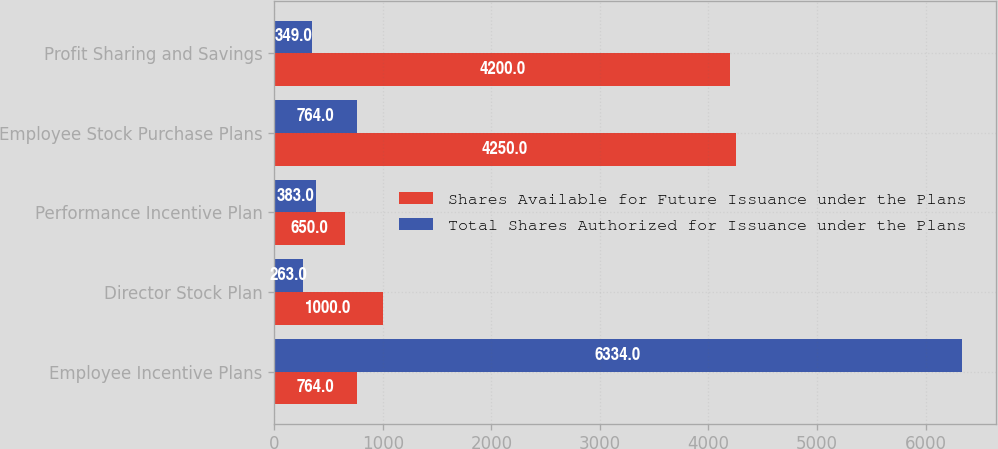Convert chart. <chart><loc_0><loc_0><loc_500><loc_500><stacked_bar_chart><ecel><fcel>Employee Incentive Plans<fcel>Director Stock Plan<fcel>Performance Incentive Plan<fcel>Employee Stock Purchase Plans<fcel>Profit Sharing and Savings<nl><fcel>Shares Available for Future Issuance under the Plans<fcel>764<fcel>1000<fcel>650<fcel>4250<fcel>4200<nl><fcel>Total Shares Authorized for Issuance under the Plans<fcel>6334<fcel>263<fcel>383<fcel>764<fcel>349<nl></chart> 